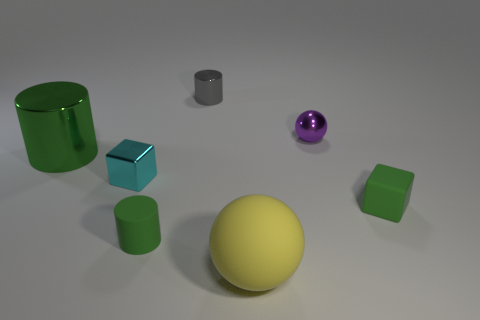There is a big object that is the same material as the purple sphere; what is its color?
Provide a short and direct response. Green. Is the number of big metal things on the right side of the small rubber cube less than the number of yellow metal balls?
Your response must be concise. No. What is the shape of the large green thing that is made of the same material as the purple object?
Provide a succinct answer. Cylinder. How many shiny objects are big balls or spheres?
Give a very brief answer. 1. Are there an equal number of tiny metallic blocks that are left of the large green metallic thing and large purple metal things?
Give a very brief answer. Yes. There is a cylinder in front of the big green cylinder; is it the same color as the small matte cube?
Your response must be concise. Yes. There is a small thing that is to the left of the gray metallic object and in front of the tiny cyan thing; what is its material?
Keep it short and to the point. Rubber. There is a green object on the left side of the metallic block; are there any small cyan cubes on the right side of it?
Your answer should be very brief. Yes. Is the big green object made of the same material as the small purple thing?
Your answer should be very brief. Yes. There is a small metal object that is on the left side of the small purple shiny sphere and in front of the tiny metallic cylinder; what shape is it?
Make the answer very short. Cube. 